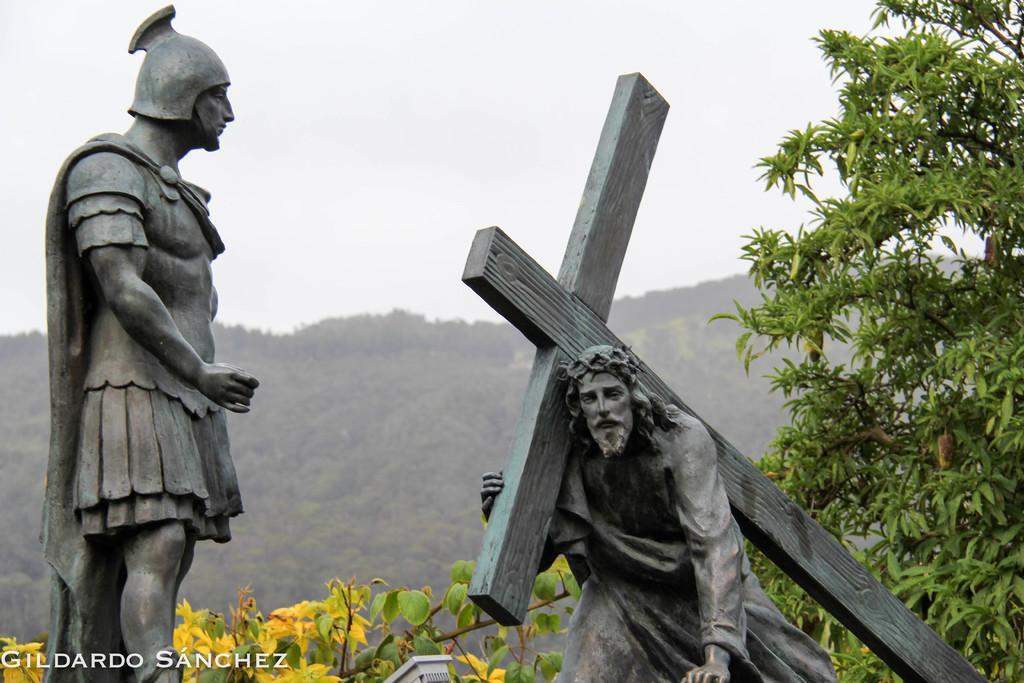Describe this image in one or two sentences. In this image we can see a statue of a person and another statue of Jesus Christ sitting on his knees and holding a cross on his shoulder. In the background there are trees and the sky. 